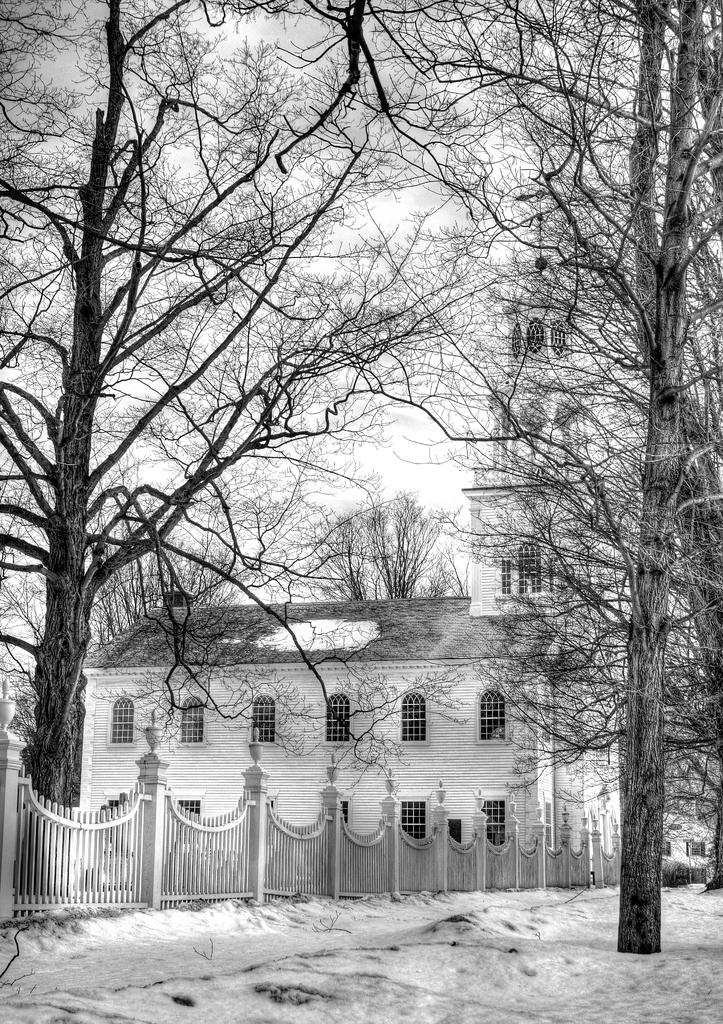What is the main feature of the landscape in the image? There is snow in the image. What structure can be seen in the image? There is a house with windows in the image. What is the purpose of the railing in the image? The railing is likely for safety or support, as it is often used in areas with steps or slopes. What type of vegetation is present in the image? There are trees to the side of the house in the image. What can be seen in the background of the image? The sky is visible in the background of the image. What type of base is used to support the ear in the image? There is no ear or base present in the image. 